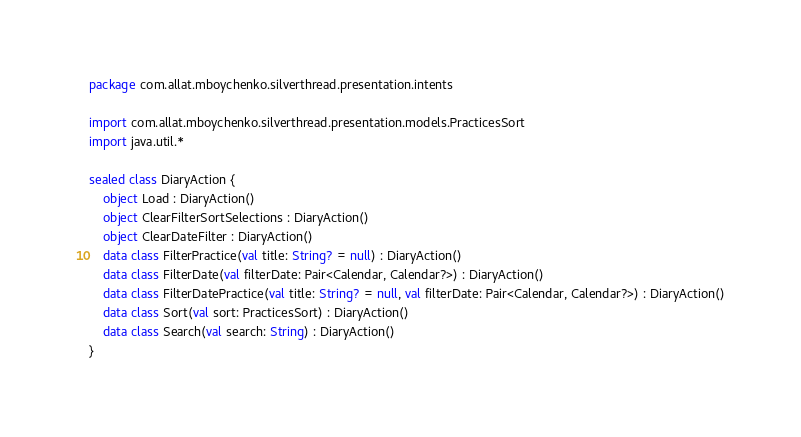Convert code to text. <code><loc_0><loc_0><loc_500><loc_500><_Kotlin_>package com.allat.mboychenko.silverthread.presentation.intents

import com.allat.mboychenko.silverthread.presentation.models.PracticesSort
import java.util.*

sealed class DiaryAction {
    object Load : DiaryAction()
    object ClearFilterSortSelections : DiaryAction()
    object ClearDateFilter : DiaryAction()
    data class FilterPractice(val title: String? = null) : DiaryAction()
    data class FilterDate(val filterDate: Pair<Calendar, Calendar?>) : DiaryAction()
    data class FilterDatePractice(val title: String? = null, val filterDate: Pair<Calendar, Calendar?>) : DiaryAction()
    data class Sort(val sort: PracticesSort) : DiaryAction()
    data class Search(val search: String) : DiaryAction()
}</code> 